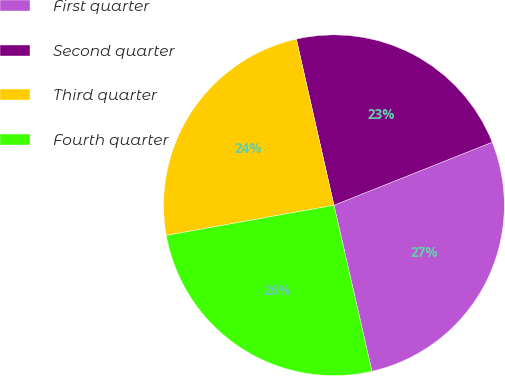<chart> <loc_0><loc_0><loc_500><loc_500><pie_chart><fcel>First quarter<fcel>Second quarter<fcel>Third quarter<fcel>Fourth quarter<nl><fcel>27.45%<fcel>22.51%<fcel>24.29%<fcel>25.74%<nl></chart> 